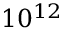<formula> <loc_0><loc_0><loc_500><loc_500>1 0 ^ { 1 2 }</formula> 